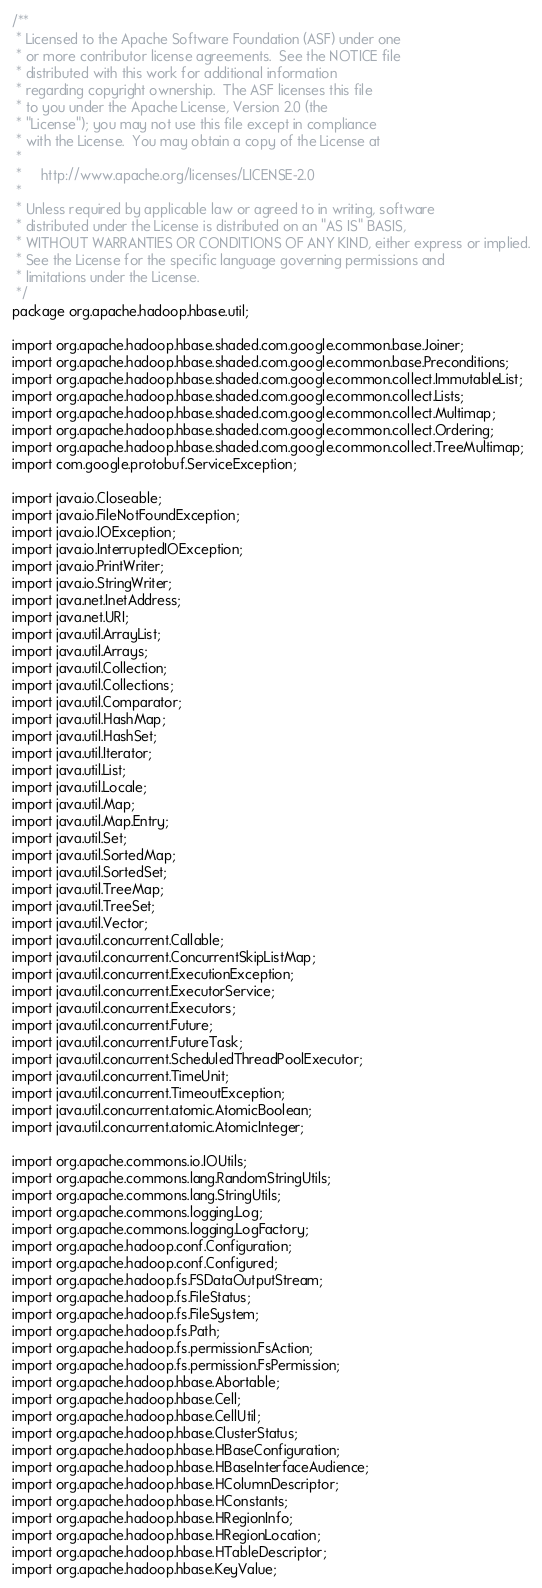Convert code to text. <code><loc_0><loc_0><loc_500><loc_500><_Java_>/**
 * Licensed to the Apache Software Foundation (ASF) under one
 * or more contributor license agreements.  See the NOTICE file
 * distributed with this work for additional information
 * regarding copyright ownership.  The ASF licenses this file
 * to you under the Apache License, Version 2.0 (the
 * "License"); you may not use this file except in compliance
 * with the License.  You may obtain a copy of the License at
 *
 *     http://www.apache.org/licenses/LICENSE-2.0
 *
 * Unless required by applicable law or agreed to in writing, software
 * distributed under the License is distributed on an "AS IS" BASIS,
 * WITHOUT WARRANTIES OR CONDITIONS OF ANY KIND, either express or implied.
 * See the License for the specific language governing permissions and
 * limitations under the License.
 */
package org.apache.hadoop.hbase.util;

import org.apache.hadoop.hbase.shaded.com.google.common.base.Joiner;
import org.apache.hadoop.hbase.shaded.com.google.common.base.Preconditions;
import org.apache.hadoop.hbase.shaded.com.google.common.collect.ImmutableList;
import org.apache.hadoop.hbase.shaded.com.google.common.collect.Lists;
import org.apache.hadoop.hbase.shaded.com.google.common.collect.Multimap;
import org.apache.hadoop.hbase.shaded.com.google.common.collect.Ordering;
import org.apache.hadoop.hbase.shaded.com.google.common.collect.TreeMultimap;
import com.google.protobuf.ServiceException;

import java.io.Closeable;
import java.io.FileNotFoundException;
import java.io.IOException;
import java.io.InterruptedIOException;
import java.io.PrintWriter;
import java.io.StringWriter;
import java.net.InetAddress;
import java.net.URI;
import java.util.ArrayList;
import java.util.Arrays;
import java.util.Collection;
import java.util.Collections;
import java.util.Comparator;
import java.util.HashMap;
import java.util.HashSet;
import java.util.Iterator;
import java.util.List;
import java.util.Locale;
import java.util.Map;
import java.util.Map.Entry;
import java.util.Set;
import java.util.SortedMap;
import java.util.SortedSet;
import java.util.TreeMap;
import java.util.TreeSet;
import java.util.Vector;
import java.util.concurrent.Callable;
import java.util.concurrent.ConcurrentSkipListMap;
import java.util.concurrent.ExecutionException;
import java.util.concurrent.ExecutorService;
import java.util.concurrent.Executors;
import java.util.concurrent.Future;
import java.util.concurrent.FutureTask;
import java.util.concurrent.ScheduledThreadPoolExecutor;
import java.util.concurrent.TimeUnit;
import java.util.concurrent.TimeoutException;
import java.util.concurrent.atomic.AtomicBoolean;
import java.util.concurrent.atomic.AtomicInteger;

import org.apache.commons.io.IOUtils;
import org.apache.commons.lang.RandomStringUtils;
import org.apache.commons.lang.StringUtils;
import org.apache.commons.logging.Log;
import org.apache.commons.logging.LogFactory;
import org.apache.hadoop.conf.Configuration;
import org.apache.hadoop.conf.Configured;
import org.apache.hadoop.fs.FSDataOutputStream;
import org.apache.hadoop.fs.FileStatus;
import org.apache.hadoop.fs.FileSystem;
import org.apache.hadoop.fs.Path;
import org.apache.hadoop.fs.permission.FsAction;
import org.apache.hadoop.fs.permission.FsPermission;
import org.apache.hadoop.hbase.Abortable;
import org.apache.hadoop.hbase.Cell;
import org.apache.hadoop.hbase.CellUtil;
import org.apache.hadoop.hbase.ClusterStatus;
import org.apache.hadoop.hbase.HBaseConfiguration;
import org.apache.hadoop.hbase.HBaseInterfaceAudience;
import org.apache.hadoop.hbase.HColumnDescriptor;
import org.apache.hadoop.hbase.HConstants;
import org.apache.hadoop.hbase.HRegionInfo;
import org.apache.hadoop.hbase.HRegionLocation;
import org.apache.hadoop.hbase.HTableDescriptor;
import org.apache.hadoop.hbase.KeyValue;</code> 